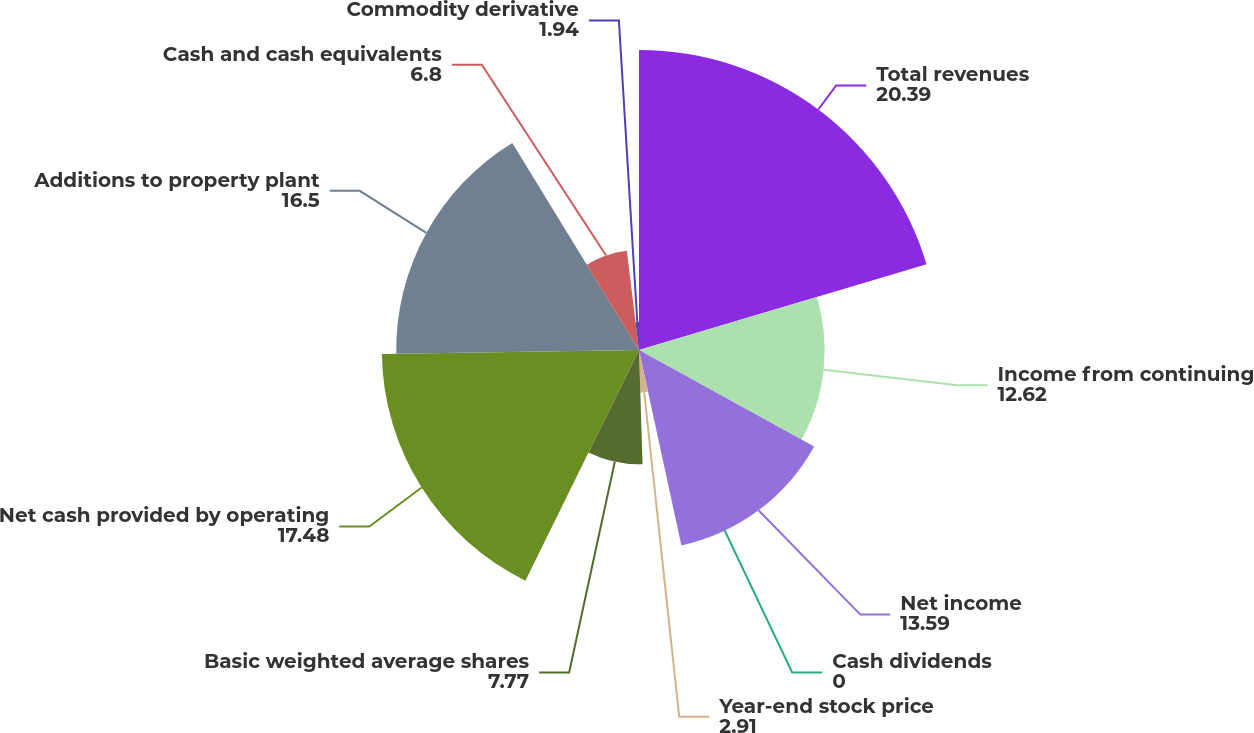Convert chart. <chart><loc_0><loc_0><loc_500><loc_500><pie_chart><fcel>Total revenues<fcel>Income from continuing<fcel>Net income<fcel>Cash dividends<fcel>Year-end stock price<fcel>Basic weighted average shares<fcel>Net cash provided by operating<fcel>Additions to property plant<fcel>Cash and cash equivalents<fcel>Commodity derivative<nl><fcel>20.39%<fcel>12.62%<fcel>13.59%<fcel>0.0%<fcel>2.91%<fcel>7.77%<fcel>17.48%<fcel>16.5%<fcel>6.8%<fcel>1.94%<nl></chart> 